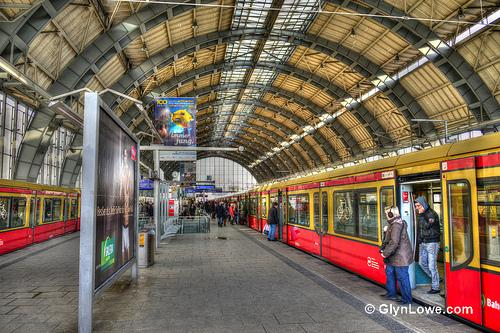What are some people doing near the train? People are walking alongside the train, getting on and off, and leaving the train car. Identify the color and additional features of the train in the image. The train is red and yellow with black trimming around the windows. Explain the appearance of one person in the image and what they are doing. A man wearing a black jacket is exiting the train. What type of sign is hanging near the ceiling in the image? A colorful sign is hung near the ceiling. Tell us something interesting about the pathways in the train station. There are stairs that lead to a lower level at the train station. Mention one detail about a person wearing headphones in the image. A person wearing headphones is preparing to get off the train. What is the appearance of the train station's ceiling? The train station has a high, domed ceiling with windows and girders mounted on it. Describe an advertisement placement in the train station. There is a large billboard sign standing on the floor of the train terminal for advertising purposes. What is a person wearing blue pants doing in the image? The person wearing blue pants is leaving the train car. Mention one distinctive feature of the train station's floor. The floor of the station is made of grey cement bricks. 